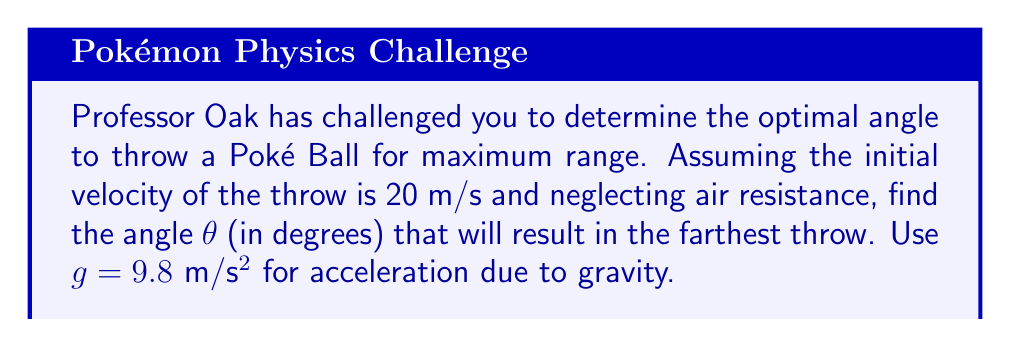Solve this math problem. Let's approach this step-by-step:

1) The range R of a projectile launched at an angle θ with initial velocity v₀ is given by:

   $$R = \frac{v_0^2 \sin(2\theta)}{g}$$

2) To find the maximum range, we need to maximize sin(2θ). This occurs when sin(2θ) = 1.

3) sin(2θ) = 1 when 2θ = 90°, or θ = 45°.

4) To verify, let's take the derivative of R with respect to θ and set it to zero:

   $$\frac{dR}{d\theta} = \frac{v_0^2}{g} \cdot 2\cos(2\theta) = 0$$

5) This equation is satisfied when cos(2θ) = 0, which occurs when 2θ = 90°, confirming our earlier result.

6) Therefore, the optimal angle for maximum range is 45°.

[asy]
import graph;
size(200,200);
real theta = pi/4;
real v0 = 1;
real g = 0.1;
real t = 2*v0*sin(theta)/g;
path trajectory = graph(new real(real t) {return v0*cos(theta)*t;},
                        new real(real t) {return v0*sin(theta)*t - 0.5*g*t^2;},
                        0, t, n=100);
draw(trajectory, blue);
draw((0,0)--(v0*cos(theta),v0*sin(theta)), arrow=Arrow(TeXHead));
label("45°", (0.2,0.2), E);
label("v₀", (0.5,0.5), NE);
xaxis(Label("x"), arrow=Arrow);
yaxis(Label("y"), arrow=Arrow);
[/asy]
Answer: 45° 